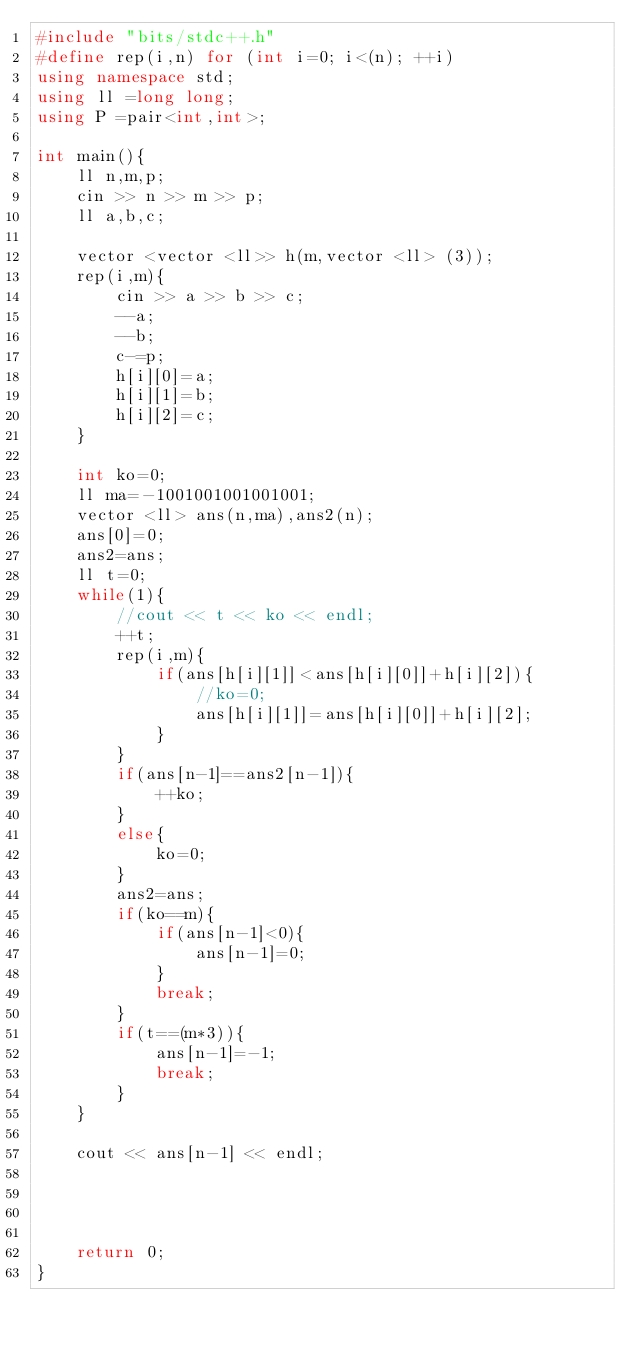Convert code to text. <code><loc_0><loc_0><loc_500><loc_500><_C++_>#include "bits/stdc++.h"
#define rep(i,n) for (int i=0; i<(n); ++i)
using namespace std;
using ll =long long;
using P =pair<int,int>;

int main(){
    ll n,m,p;
    cin >> n >> m >> p;
    ll a,b,c;

    vector <vector <ll>> h(m,vector <ll> (3));
    rep(i,m){
        cin >> a >> b >> c;
        --a;
        --b;
        c-=p;
        h[i][0]=a;
        h[i][1]=b;
        h[i][2]=c;
    }

    int ko=0;
    ll ma=-1001001001001001;
    vector <ll> ans(n,ma),ans2(n);
    ans[0]=0;
    ans2=ans;
    ll t=0;
    while(1){
        //cout << t << ko << endl;
        ++t;
        rep(i,m){
            if(ans[h[i][1]]<ans[h[i][0]]+h[i][2]){
                //ko=0;
                ans[h[i][1]]=ans[h[i][0]]+h[i][2];
            }
        }
        if(ans[n-1]==ans2[n-1]){
            ++ko;
        }
        else{
            ko=0;
        }
        ans2=ans;
        if(ko==m){
            if(ans[n-1]<0){
                ans[n-1]=0;
            }
            break;
        }
        if(t==(m*3)){
            ans[n-1]=-1;
            break;
        }
    }

    cout << ans[n-1] << endl;


    

    return 0;
}</code> 